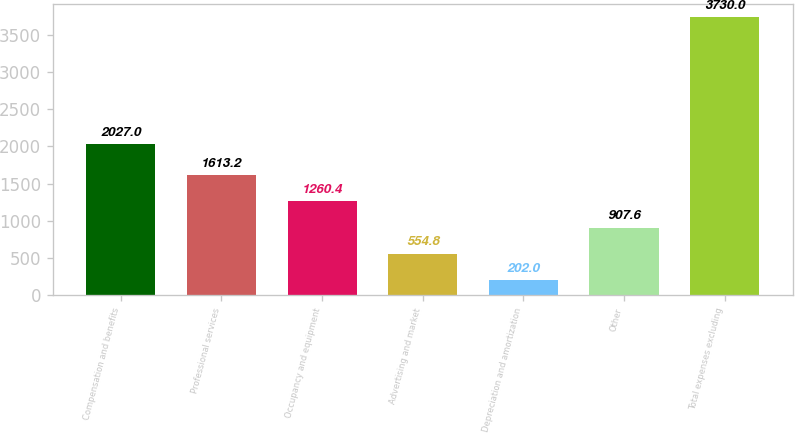Convert chart to OTSL. <chart><loc_0><loc_0><loc_500><loc_500><bar_chart><fcel>Compensation and benefits<fcel>Professional services<fcel>Occupancy and equipment<fcel>Advertising and market<fcel>Depreciation and amortization<fcel>Other<fcel>Total expenses excluding<nl><fcel>2027<fcel>1613.2<fcel>1260.4<fcel>554.8<fcel>202<fcel>907.6<fcel>3730<nl></chart> 